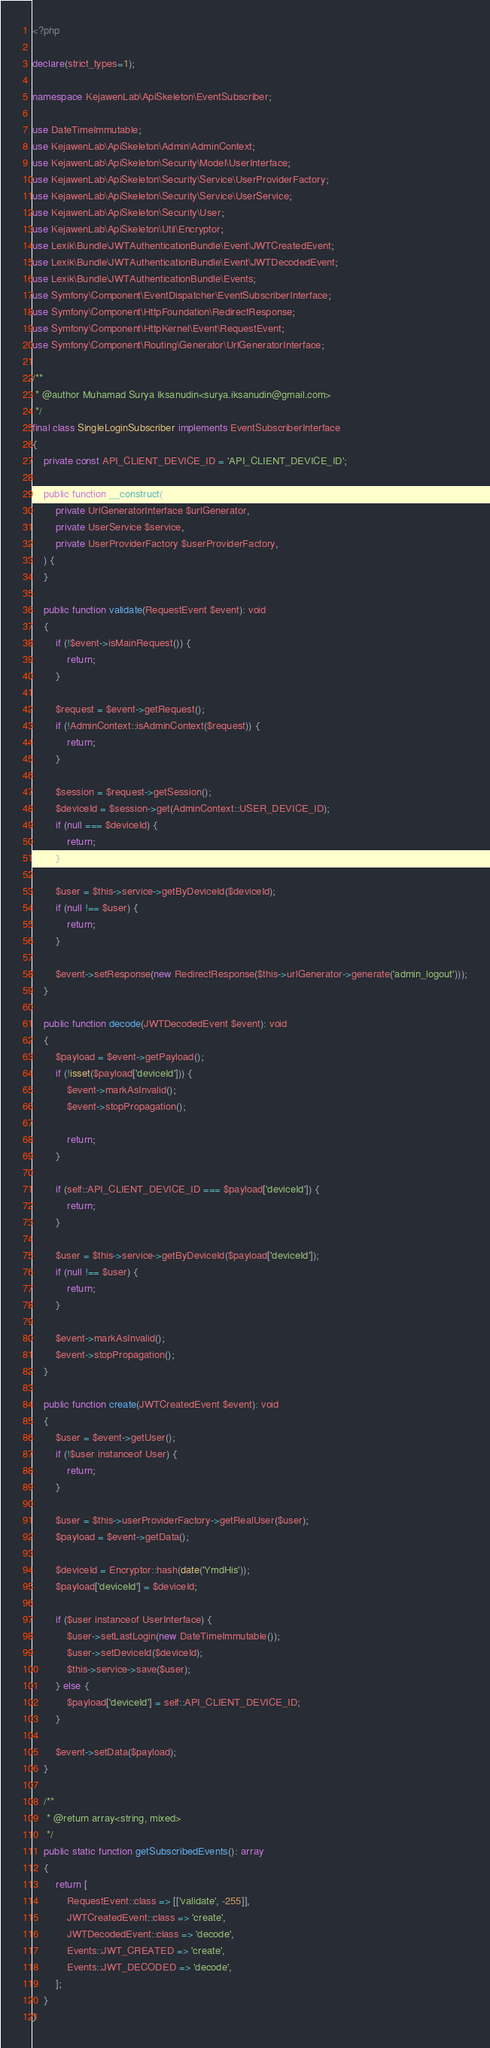Convert code to text. <code><loc_0><loc_0><loc_500><loc_500><_PHP_><?php

declare(strict_types=1);

namespace KejawenLab\ApiSkeleton\EventSubscriber;

use DateTimeImmutable;
use KejawenLab\ApiSkeleton\Admin\AdminContext;
use KejawenLab\ApiSkeleton\Security\Model\UserInterface;
use KejawenLab\ApiSkeleton\Security\Service\UserProviderFactory;
use KejawenLab\ApiSkeleton\Security\Service\UserService;
use KejawenLab\ApiSkeleton\Security\User;
use KejawenLab\ApiSkeleton\Util\Encryptor;
use Lexik\Bundle\JWTAuthenticationBundle\Event\JWTCreatedEvent;
use Lexik\Bundle\JWTAuthenticationBundle\Event\JWTDecodedEvent;
use Lexik\Bundle\JWTAuthenticationBundle\Events;
use Symfony\Component\EventDispatcher\EventSubscriberInterface;
use Symfony\Component\HttpFoundation\RedirectResponse;
use Symfony\Component\HttpKernel\Event\RequestEvent;
use Symfony\Component\Routing\Generator\UrlGeneratorInterface;

/**
 * @author Muhamad Surya Iksanudin<surya.iksanudin@gmail.com>
 */
final class SingleLoginSubscriber implements EventSubscriberInterface
{
    private const API_CLIENT_DEVICE_ID = 'API_CLIENT_DEVICE_ID';

    public function __construct(
        private UrlGeneratorInterface $urlGenerator,
        private UserService $service,
        private UserProviderFactory $userProviderFactory,
    ) {
    }

    public function validate(RequestEvent $event): void
    {
        if (!$event->isMainRequest()) {
            return;
        }

        $request = $event->getRequest();
        if (!AdminContext::isAdminContext($request)) {
            return;
        }

        $session = $request->getSession();
        $deviceId = $session->get(AdminContext::USER_DEVICE_ID);
        if (null === $deviceId) {
            return;
        }

        $user = $this->service->getByDeviceId($deviceId);
        if (null !== $user) {
            return;
        }

        $event->setResponse(new RedirectResponse($this->urlGenerator->generate('admin_logout')));
    }

    public function decode(JWTDecodedEvent $event): void
    {
        $payload = $event->getPayload();
        if (!isset($payload['deviceId'])) {
            $event->markAsInvalid();
            $event->stopPropagation();

            return;
        }

        if (self::API_CLIENT_DEVICE_ID === $payload['deviceId']) {
            return;
        }

        $user = $this->service->getByDeviceId($payload['deviceId']);
        if (null !== $user) {
            return;
        }

        $event->markAsInvalid();
        $event->stopPropagation();
    }

    public function create(JWTCreatedEvent $event): void
    {
        $user = $event->getUser();
        if (!$user instanceof User) {
            return;
        }

        $user = $this->userProviderFactory->getRealUser($user);
        $payload = $event->getData();

        $deviceId = Encryptor::hash(date('YmdHis'));
        $payload['deviceId'] = $deviceId;

        if ($user instanceof UserInterface) {
            $user->setLastLogin(new DateTimeImmutable());
            $user->setDeviceId($deviceId);
            $this->service->save($user);
        } else {
            $payload['deviceId'] = self::API_CLIENT_DEVICE_ID;
        }

        $event->setData($payload);
    }

    /**
     * @return array<string, mixed>
     */
    public static function getSubscribedEvents(): array
    {
        return [
            RequestEvent::class => [['validate', -255]],
            JWTCreatedEvent::class => 'create',
            JWTDecodedEvent::class => 'decode',
            Events::JWT_CREATED => 'create',
            Events::JWT_DECODED => 'decode',
        ];
    }
}
</code> 